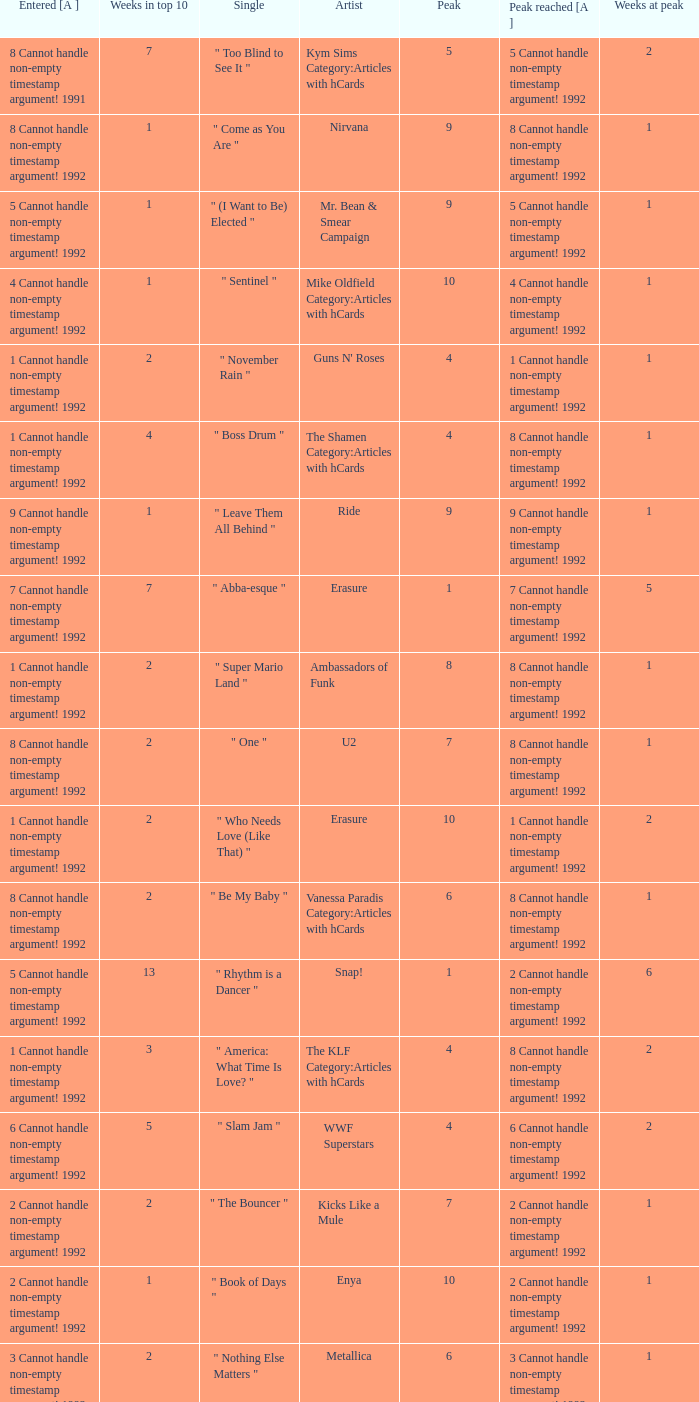If the peak reached is 6 cannot handle non-empty timestamp argument! 1992, what is the entered? 6 Cannot handle non-empty timestamp argument! 1992. 